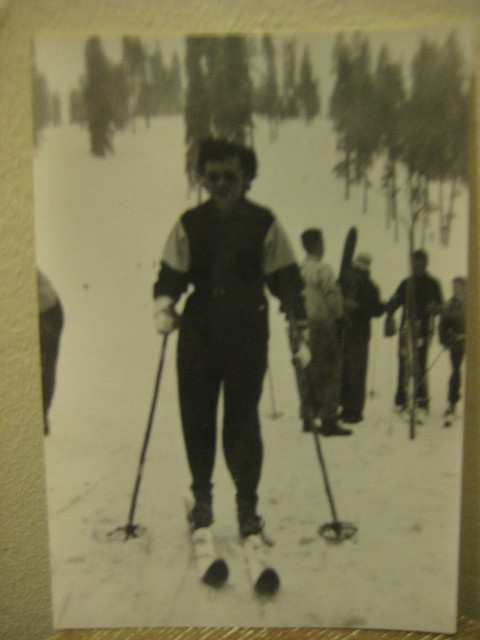Describe the objects in this image and their specific colors. I can see people in olive, black, tan, darkgreen, and gray tones, people in olive, black, darkgreen, and gray tones, people in olive, black, darkgreen, and gray tones, people in olive, black, darkgreen, and gray tones, and skis in olive, gray, black, and darkgreen tones in this image. 